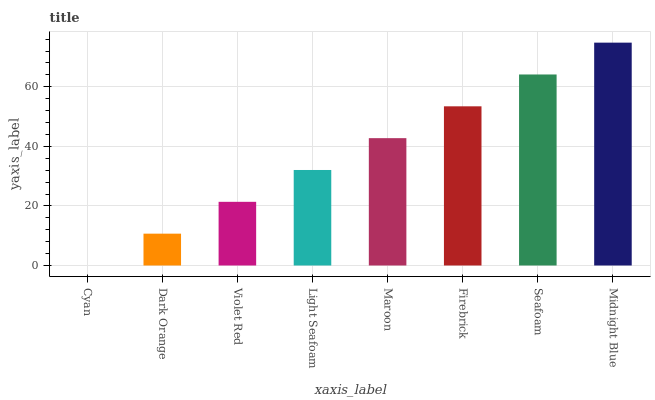Is Dark Orange the minimum?
Answer yes or no. No. Is Dark Orange the maximum?
Answer yes or no. No. Is Dark Orange greater than Cyan?
Answer yes or no. Yes. Is Cyan less than Dark Orange?
Answer yes or no. Yes. Is Cyan greater than Dark Orange?
Answer yes or no. No. Is Dark Orange less than Cyan?
Answer yes or no. No. Is Maroon the high median?
Answer yes or no. Yes. Is Light Seafoam the low median?
Answer yes or no. Yes. Is Violet Red the high median?
Answer yes or no. No. Is Violet Red the low median?
Answer yes or no. No. 